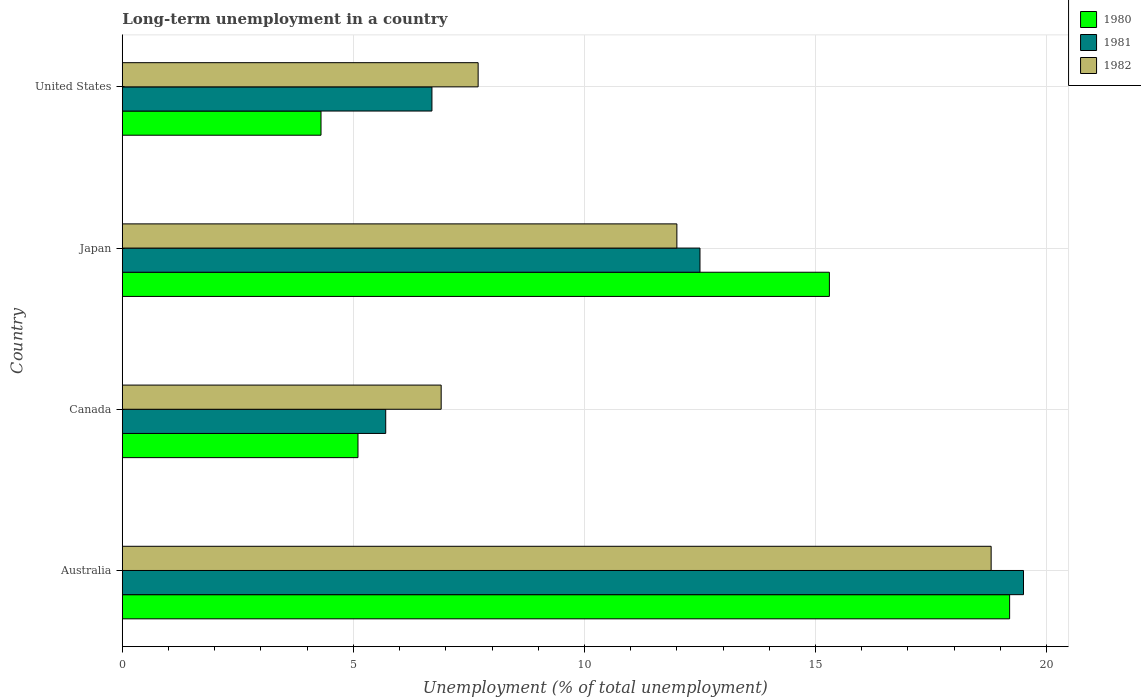How many different coloured bars are there?
Your answer should be compact. 3. How many groups of bars are there?
Make the answer very short. 4. What is the percentage of long-term unemployed population in 1980 in Canada?
Keep it short and to the point. 5.1. Across all countries, what is the maximum percentage of long-term unemployed population in 1982?
Offer a very short reply. 18.8. Across all countries, what is the minimum percentage of long-term unemployed population in 1981?
Your response must be concise. 5.7. In which country was the percentage of long-term unemployed population in 1982 maximum?
Give a very brief answer. Australia. What is the total percentage of long-term unemployed population in 1981 in the graph?
Provide a short and direct response. 44.4. What is the difference between the percentage of long-term unemployed population in 1980 in Australia and that in Canada?
Keep it short and to the point. 14.1. What is the difference between the percentage of long-term unemployed population in 1980 in Japan and the percentage of long-term unemployed population in 1981 in United States?
Give a very brief answer. 8.6. What is the average percentage of long-term unemployed population in 1981 per country?
Give a very brief answer. 11.1. What is the difference between the percentage of long-term unemployed population in 1980 and percentage of long-term unemployed population in 1982 in Australia?
Offer a terse response. 0.4. In how many countries, is the percentage of long-term unemployed population in 1982 greater than 19 %?
Give a very brief answer. 0. What is the ratio of the percentage of long-term unemployed population in 1981 in Australia to that in Canada?
Make the answer very short. 3.42. Is the difference between the percentage of long-term unemployed population in 1980 in Japan and United States greater than the difference between the percentage of long-term unemployed population in 1982 in Japan and United States?
Provide a succinct answer. Yes. What is the difference between the highest and the second highest percentage of long-term unemployed population in 1981?
Ensure brevity in your answer.  7. What is the difference between the highest and the lowest percentage of long-term unemployed population in 1982?
Provide a succinct answer. 11.9. What does the 2nd bar from the top in Japan represents?
Make the answer very short. 1981. Is it the case that in every country, the sum of the percentage of long-term unemployed population in 1980 and percentage of long-term unemployed population in 1982 is greater than the percentage of long-term unemployed population in 1981?
Ensure brevity in your answer.  Yes. How many bars are there?
Provide a succinct answer. 12. Are the values on the major ticks of X-axis written in scientific E-notation?
Your answer should be compact. No. Does the graph contain grids?
Give a very brief answer. Yes. Where does the legend appear in the graph?
Your answer should be very brief. Top right. How are the legend labels stacked?
Give a very brief answer. Vertical. What is the title of the graph?
Offer a very short reply. Long-term unemployment in a country. What is the label or title of the X-axis?
Your answer should be very brief. Unemployment (% of total unemployment). What is the label or title of the Y-axis?
Your answer should be compact. Country. What is the Unemployment (% of total unemployment) in 1980 in Australia?
Offer a terse response. 19.2. What is the Unemployment (% of total unemployment) in 1982 in Australia?
Provide a short and direct response. 18.8. What is the Unemployment (% of total unemployment) of 1980 in Canada?
Make the answer very short. 5.1. What is the Unemployment (% of total unemployment) in 1981 in Canada?
Make the answer very short. 5.7. What is the Unemployment (% of total unemployment) in 1982 in Canada?
Your response must be concise. 6.9. What is the Unemployment (% of total unemployment) of 1980 in Japan?
Make the answer very short. 15.3. What is the Unemployment (% of total unemployment) of 1982 in Japan?
Your response must be concise. 12. What is the Unemployment (% of total unemployment) in 1980 in United States?
Your answer should be very brief. 4.3. What is the Unemployment (% of total unemployment) of 1981 in United States?
Keep it short and to the point. 6.7. What is the Unemployment (% of total unemployment) in 1982 in United States?
Give a very brief answer. 7.7. Across all countries, what is the maximum Unemployment (% of total unemployment) in 1980?
Your answer should be very brief. 19.2. Across all countries, what is the maximum Unemployment (% of total unemployment) in 1982?
Provide a succinct answer. 18.8. Across all countries, what is the minimum Unemployment (% of total unemployment) in 1980?
Ensure brevity in your answer.  4.3. Across all countries, what is the minimum Unemployment (% of total unemployment) in 1981?
Make the answer very short. 5.7. Across all countries, what is the minimum Unemployment (% of total unemployment) of 1982?
Make the answer very short. 6.9. What is the total Unemployment (% of total unemployment) of 1980 in the graph?
Offer a terse response. 43.9. What is the total Unemployment (% of total unemployment) in 1981 in the graph?
Your answer should be compact. 44.4. What is the total Unemployment (% of total unemployment) of 1982 in the graph?
Make the answer very short. 45.4. What is the difference between the Unemployment (% of total unemployment) of 1981 in Australia and that in Canada?
Ensure brevity in your answer.  13.8. What is the difference between the Unemployment (% of total unemployment) of 1982 in Australia and that in Canada?
Your answer should be very brief. 11.9. What is the difference between the Unemployment (% of total unemployment) of 1980 in Australia and that in Japan?
Provide a short and direct response. 3.9. What is the difference between the Unemployment (% of total unemployment) of 1981 in Australia and that in Japan?
Ensure brevity in your answer.  7. What is the difference between the Unemployment (% of total unemployment) of 1980 in Australia and that in United States?
Keep it short and to the point. 14.9. What is the difference between the Unemployment (% of total unemployment) of 1982 in Australia and that in United States?
Offer a terse response. 11.1. What is the difference between the Unemployment (% of total unemployment) in 1982 in Canada and that in Japan?
Your answer should be very brief. -5.1. What is the difference between the Unemployment (% of total unemployment) of 1980 in Canada and that in United States?
Ensure brevity in your answer.  0.8. What is the difference between the Unemployment (% of total unemployment) of 1980 in Japan and that in United States?
Offer a terse response. 11. What is the difference between the Unemployment (% of total unemployment) in 1982 in Japan and that in United States?
Your answer should be compact. 4.3. What is the difference between the Unemployment (% of total unemployment) in 1980 in Australia and the Unemployment (% of total unemployment) in 1981 in Canada?
Your answer should be compact. 13.5. What is the difference between the Unemployment (% of total unemployment) in 1980 in Australia and the Unemployment (% of total unemployment) in 1982 in Japan?
Offer a very short reply. 7.2. What is the difference between the Unemployment (% of total unemployment) in 1980 in Canada and the Unemployment (% of total unemployment) in 1981 in Japan?
Make the answer very short. -7.4. What is the difference between the Unemployment (% of total unemployment) in 1980 in Canada and the Unemployment (% of total unemployment) in 1982 in United States?
Your answer should be compact. -2.6. What is the difference between the Unemployment (% of total unemployment) in 1981 in Canada and the Unemployment (% of total unemployment) in 1982 in United States?
Keep it short and to the point. -2. What is the difference between the Unemployment (% of total unemployment) in 1981 in Japan and the Unemployment (% of total unemployment) in 1982 in United States?
Keep it short and to the point. 4.8. What is the average Unemployment (% of total unemployment) in 1980 per country?
Make the answer very short. 10.97. What is the average Unemployment (% of total unemployment) in 1981 per country?
Provide a short and direct response. 11.1. What is the average Unemployment (% of total unemployment) in 1982 per country?
Offer a terse response. 11.35. What is the difference between the Unemployment (% of total unemployment) of 1981 and Unemployment (% of total unemployment) of 1982 in Australia?
Ensure brevity in your answer.  0.7. What is the difference between the Unemployment (% of total unemployment) of 1980 and Unemployment (% of total unemployment) of 1982 in Canada?
Your response must be concise. -1.8. What is the difference between the Unemployment (% of total unemployment) of 1981 and Unemployment (% of total unemployment) of 1982 in Canada?
Offer a very short reply. -1.2. What is the difference between the Unemployment (% of total unemployment) in 1980 and Unemployment (% of total unemployment) in 1981 in Japan?
Offer a terse response. 2.8. What is the difference between the Unemployment (% of total unemployment) in 1981 and Unemployment (% of total unemployment) in 1982 in Japan?
Provide a short and direct response. 0.5. What is the difference between the Unemployment (% of total unemployment) in 1980 and Unemployment (% of total unemployment) in 1982 in United States?
Give a very brief answer. -3.4. What is the difference between the Unemployment (% of total unemployment) of 1981 and Unemployment (% of total unemployment) of 1982 in United States?
Offer a very short reply. -1. What is the ratio of the Unemployment (% of total unemployment) of 1980 in Australia to that in Canada?
Your answer should be compact. 3.76. What is the ratio of the Unemployment (% of total unemployment) of 1981 in Australia to that in Canada?
Offer a terse response. 3.42. What is the ratio of the Unemployment (% of total unemployment) of 1982 in Australia to that in Canada?
Your answer should be compact. 2.72. What is the ratio of the Unemployment (% of total unemployment) in 1980 in Australia to that in Japan?
Make the answer very short. 1.25. What is the ratio of the Unemployment (% of total unemployment) in 1981 in Australia to that in Japan?
Ensure brevity in your answer.  1.56. What is the ratio of the Unemployment (% of total unemployment) in 1982 in Australia to that in Japan?
Your answer should be compact. 1.57. What is the ratio of the Unemployment (% of total unemployment) in 1980 in Australia to that in United States?
Your answer should be compact. 4.47. What is the ratio of the Unemployment (% of total unemployment) of 1981 in Australia to that in United States?
Give a very brief answer. 2.91. What is the ratio of the Unemployment (% of total unemployment) in 1982 in Australia to that in United States?
Your answer should be compact. 2.44. What is the ratio of the Unemployment (% of total unemployment) in 1980 in Canada to that in Japan?
Keep it short and to the point. 0.33. What is the ratio of the Unemployment (% of total unemployment) in 1981 in Canada to that in Japan?
Provide a short and direct response. 0.46. What is the ratio of the Unemployment (% of total unemployment) of 1982 in Canada to that in Japan?
Provide a short and direct response. 0.57. What is the ratio of the Unemployment (% of total unemployment) in 1980 in Canada to that in United States?
Your answer should be compact. 1.19. What is the ratio of the Unemployment (% of total unemployment) of 1981 in Canada to that in United States?
Make the answer very short. 0.85. What is the ratio of the Unemployment (% of total unemployment) of 1982 in Canada to that in United States?
Provide a short and direct response. 0.9. What is the ratio of the Unemployment (% of total unemployment) in 1980 in Japan to that in United States?
Your answer should be compact. 3.56. What is the ratio of the Unemployment (% of total unemployment) of 1981 in Japan to that in United States?
Offer a very short reply. 1.87. What is the ratio of the Unemployment (% of total unemployment) in 1982 in Japan to that in United States?
Provide a succinct answer. 1.56. What is the difference between the highest and the second highest Unemployment (% of total unemployment) in 1980?
Ensure brevity in your answer.  3.9. What is the difference between the highest and the second highest Unemployment (% of total unemployment) in 1981?
Provide a succinct answer. 7. 